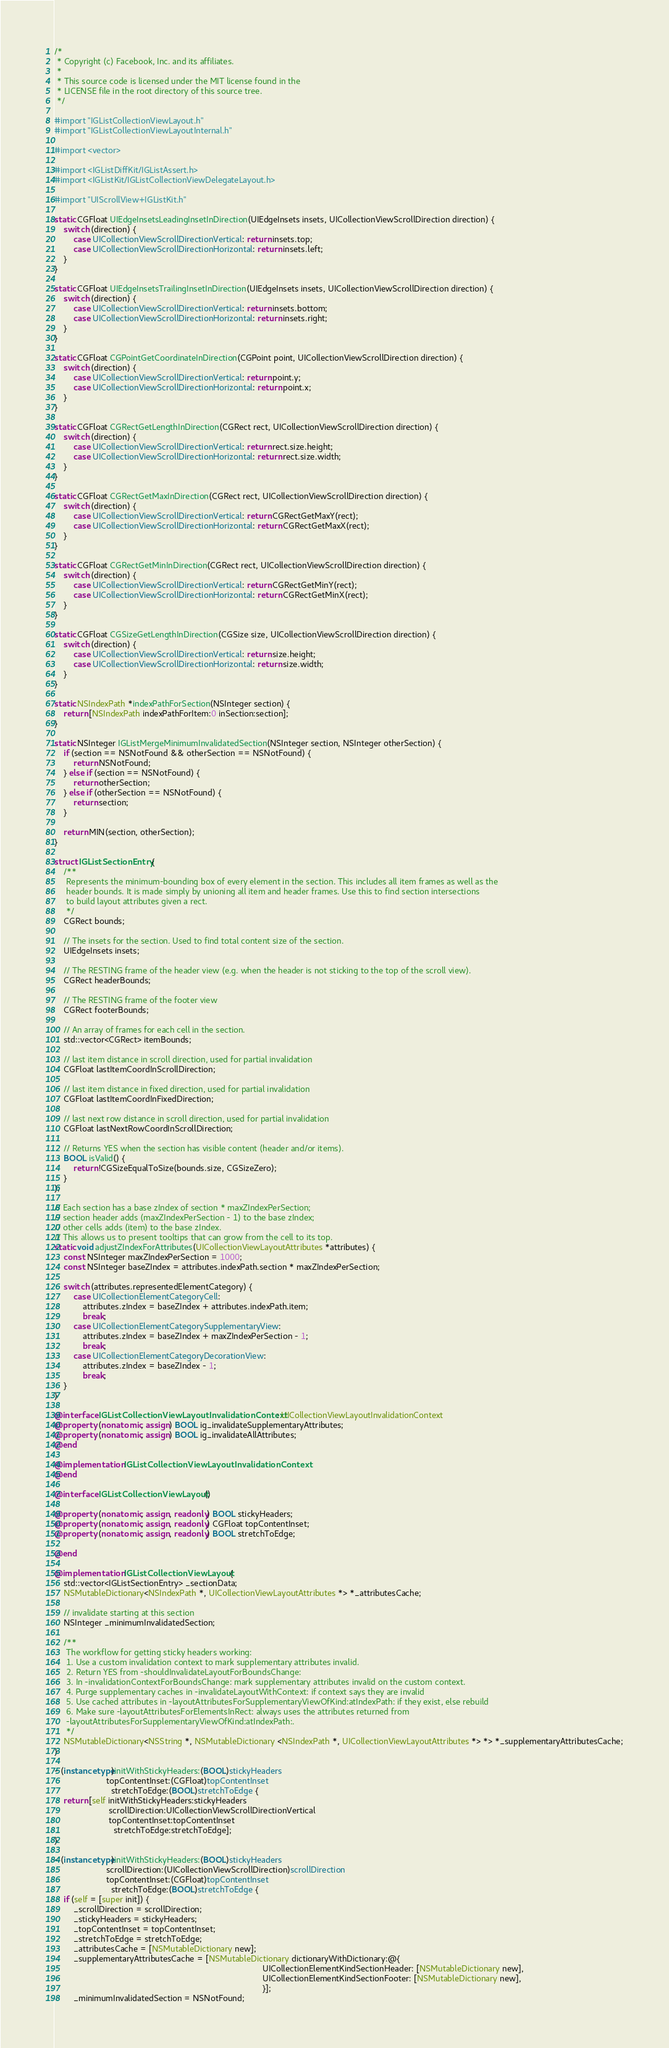<code> <loc_0><loc_0><loc_500><loc_500><_ObjectiveC_>/*
 * Copyright (c) Facebook, Inc. and its affiliates.
 *
 * This source code is licensed under the MIT license found in the
 * LICENSE file in the root directory of this source tree.
 */

#import "IGListCollectionViewLayout.h"
#import "IGListCollectionViewLayoutInternal.h"

#import <vector>

#import <IGListDiffKit/IGListAssert.h>
#import <IGListKit/IGListCollectionViewDelegateLayout.h>

#import "UIScrollView+IGListKit.h"

static CGFloat UIEdgeInsetsLeadingInsetInDirection(UIEdgeInsets insets, UICollectionViewScrollDirection direction) {
    switch (direction) {
        case UICollectionViewScrollDirectionVertical: return insets.top;
        case UICollectionViewScrollDirectionHorizontal: return insets.left;
    }
}

static CGFloat UIEdgeInsetsTrailingInsetInDirection(UIEdgeInsets insets, UICollectionViewScrollDirection direction) {
    switch (direction) {
        case UICollectionViewScrollDirectionVertical: return insets.bottom;
        case UICollectionViewScrollDirectionHorizontal: return insets.right;
    }
}

static CGFloat CGPointGetCoordinateInDirection(CGPoint point, UICollectionViewScrollDirection direction) {
    switch (direction) {
        case UICollectionViewScrollDirectionVertical: return point.y;
        case UICollectionViewScrollDirectionHorizontal: return point.x;
    }
}

static CGFloat CGRectGetLengthInDirection(CGRect rect, UICollectionViewScrollDirection direction) {
    switch (direction) {
        case UICollectionViewScrollDirectionVertical: return rect.size.height;
        case UICollectionViewScrollDirectionHorizontal: return rect.size.width;
    }
}

static CGFloat CGRectGetMaxInDirection(CGRect rect, UICollectionViewScrollDirection direction) {
    switch (direction) {
        case UICollectionViewScrollDirectionVertical: return CGRectGetMaxY(rect);
        case UICollectionViewScrollDirectionHorizontal: return CGRectGetMaxX(rect);
    }
}

static CGFloat CGRectGetMinInDirection(CGRect rect, UICollectionViewScrollDirection direction) {
    switch (direction) {
        case UICollectionViewScrollDirectionVertical: return CGRectGetMinY(rect);
        case UICollectionViewScrollDirectionHorizontal: return CGRectGetMinX(rect);
    }
}

static CGFloat CGSizeGetLengthInDirection(CGSize size, UICollectionViewScrollDirection direction) {
    switch (direction) {
        case UICollectionViewScrollDirectionVertical: return size.height;
        case UICollectionViewScrollDirectionHorizontal: return size.width;
    }
}

static NSIndexPath *indexPathForSection(NSInteger section) {
    return [NSIndexPath indexPathForItem:0 inSection:section];
}

static NSInteger IGListMergeMinimumInvalidatedSection(NSInteger section, NSInteger otherSection) {
    if (section == NSNotFound && otherSection == NSNotFound) {
        return NSNotFound;
    } else if (section == NSNotFound) {
        return otherSection;
    } else if (otherSection == NSNotFound) {
        return section;
    }

    return MIN(section, otherSection);
}

struct IGListSectionEntry {
    /**
     Represents the minimum-bounding box of every element in the section. This includes all item frames as well as the
     header bounds. It is made simply by unioning all item and header frames. Use this to find section intersections
     to build layout attributes given a rect.
     */
    CGRect bounds;

    // The insets for the section. Used to find total content size of the section.
    UIEdgeInsets insets;

    // The RESTING frame of the header view (e.g. when the header is not sticking to the top of the scroll view).
    CGRect headerBounds;

    // The RESTING frame of the footer view
    CGRect footerBounds;

    // An array of frames for each cell in the section.
    std::vector<CGRect> itemBounds;

    // last item distance in scroll direction, used for partial invalidation
    CGFloat lastItemCoordInScrollDirection;

    // last item distance in fixed direction, used for partial invalidation
    CGFloat lastItemCoordInFixedDirection;

    // last next row distance in scroll direction, used for partial invalidation
    CGFloat lastNextRowCoordInScrollDirection;

    // Returns YES when the section has visible content (header and/or items).
    BOOL isValid() {
        return !CGSizeEqualToSize(bounds.size, CGSizeZero);
    }
};

// Each section has a base zIndex of section * maxZIndexPerSection;
// section header adds (maxZIndexPerSection - 1) to the base zIndex;
// other cells adds (item) to the base zIndex.
// This allows us to present tooltips that can grow from the cell to its top.
static void adjustZIndexForAttributes(UICollectionViewLayoutAttributes *attributes) {
    const NSInteger maxZIndexPerSection = 1000;
    const NSInteger baseZIndex = attributes.indexPath.section * maxZIndexPerSection;

    switch (attributes.representedElementCategory) {
        case UICollectionElementCategoryCell:
            attributes.zIndex = baseZIndex + attributes.indexPath.item;
            break;
        case UICollectionElementCategorySupplementaryView:
            attributes.zIndex = baseZIndex + maxZIndexPerSection - 1;
            break;
        case UICollectionElementCategoryDecorationView:
            attributes.zIndex = baseZIndex - 1;
            break;
    }
}

@interface IGListCollectionViewLayoutInvalidationContext : UICollectionViewLayoutInvalidationContext
@property (nonatomic, assign) BOOL ig_invalidateSupplementaryAttributes;
@property (nonatomic, assign) BOOL ig_invalidateAllAttributes;
@end

@implementation IGListCollectionViewLayoutInvalidationContext
@end

@interface IGListCollectionViewLayout ()

@property (nonatomic, assign, readonly) BOOL stickyHeaders;
@property (nonatomic, assign, readonly) CGFloat topContentInset;
@property (nonatomic, assign, readonly) BOOL stretchToEdge;

@end

@implementation IGListCollectionViewLayout {
    std::vector<IGListSectionEntry> _sectionData;
    NSMutableDictionary<NSIndexPath *, UICollectionViewLayoutAttributes *> *_attributesCache;

    // invalidate starting at this section
    NSInteger _minimumInvalidatedSection;

    /**
     The workflow for getting sticky headers working:
     1. Use a custom invalidation context to mark supplementary attributes invalid.
     2. Return YES from -shouldInvalidateLayoutForBoundsChange:
     3. In -invalidationContextForBoundsChange: mark supplementary attributes invalid on the custom context.
     4. Purge supplementary caches in -invalidateLayoutWithContext: if context says they are invalid
     5. Use cached attributes in -layoutAttributesForSupplementaryViewOfKind:atIndexPath: if they exist, else rebuild
     6. Make sure -layoutAttributesForElementsInRect: always uses the attributes returned from
     -layoutAttributesForSupplementaryViewOfKind:atIndexPath:.
     */
    NSMutableDictionary<NSString *, NSMutableDictionary <NSIndexPath *, UICollectionViewLayoutAttributes *> *> *_supplementaryAttributesCache;
}

- (instancetype)initWithStickyHeaders:(BOOL)stickyHeaders
                      topContentInset:(CGFloat)topContentInset
                        stretchToEdge:(BOOL)stretchToEdge {
    return [self initWithStickyHeaders:stickyHeaders
                       scrollDirection:UICollectionViewScrollDirectionVertical
                       topContentInset:topContentInset
                         stretchToEdge:stretchToEdge];
}

- (instancetype)initWithStickyHeaders:(BOOL)stickyHeaders
                      scrollDirection:(UICollectionViewScrollDirection)scrollDirection
                      topContentInset:(CGFloat)topContentInset
                        stretchToEdge:(BOOL)stretchToEdge {
    if (self = [super init]) {
        _scrollDirection = scrollDirection;
        _stickyHeaders = stickyHeaders;
        _topContentInset = topContentInset;
        _stretchToEdge = stretchToEdge;
        _attributesCache = [NSMutableDictionary new];
        _supplementaryAttributesCache = [NSMutableDictionary dictionaryWithDictionary:@{
                                                                                        UICollectionElementKindSectionHeader: [NSMutableDictionary new],
                                                                                        UICollectionElementKindSectionFooter: [NSMutableDictionary new],
                                                                                        }];
        _minimumInvalidatedSection = NSNotFound;</code> 